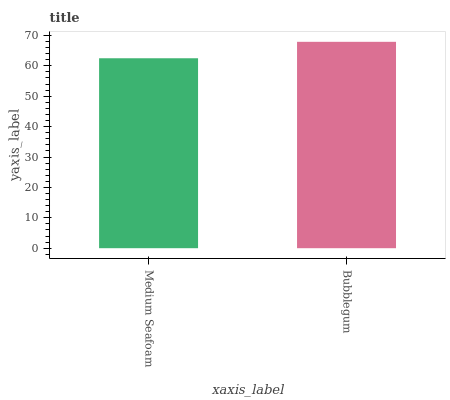Is Medium Seafoam the minimum?
Answer yes or no. Yes. Is Bubblegum the maximum?
Answer yes or no. Yes. Is Bubblegum the minimum?
Answer yes or no. No. Is Bubblegum greater than Medium Seafoam?
Answer yes or no. Yes. Is Medium Seafoam less than Bubblegum?
Answer yes or no. Yes. Is Medium Seafoam greater than Bubblegum?
Answer yes or no. No. Is Bubblegum less than Medium Seafoam?
Answer yes or no. No. Is Bubblegum the high median?
Answer yes or no. Yes. Is Medium Seafoam the low median?
Answer yes or no. Yes. Is Medium Seafoam the high median?
Answer yes or no. No. Is Bubblegum the low median?
Answer yes or no. No. 